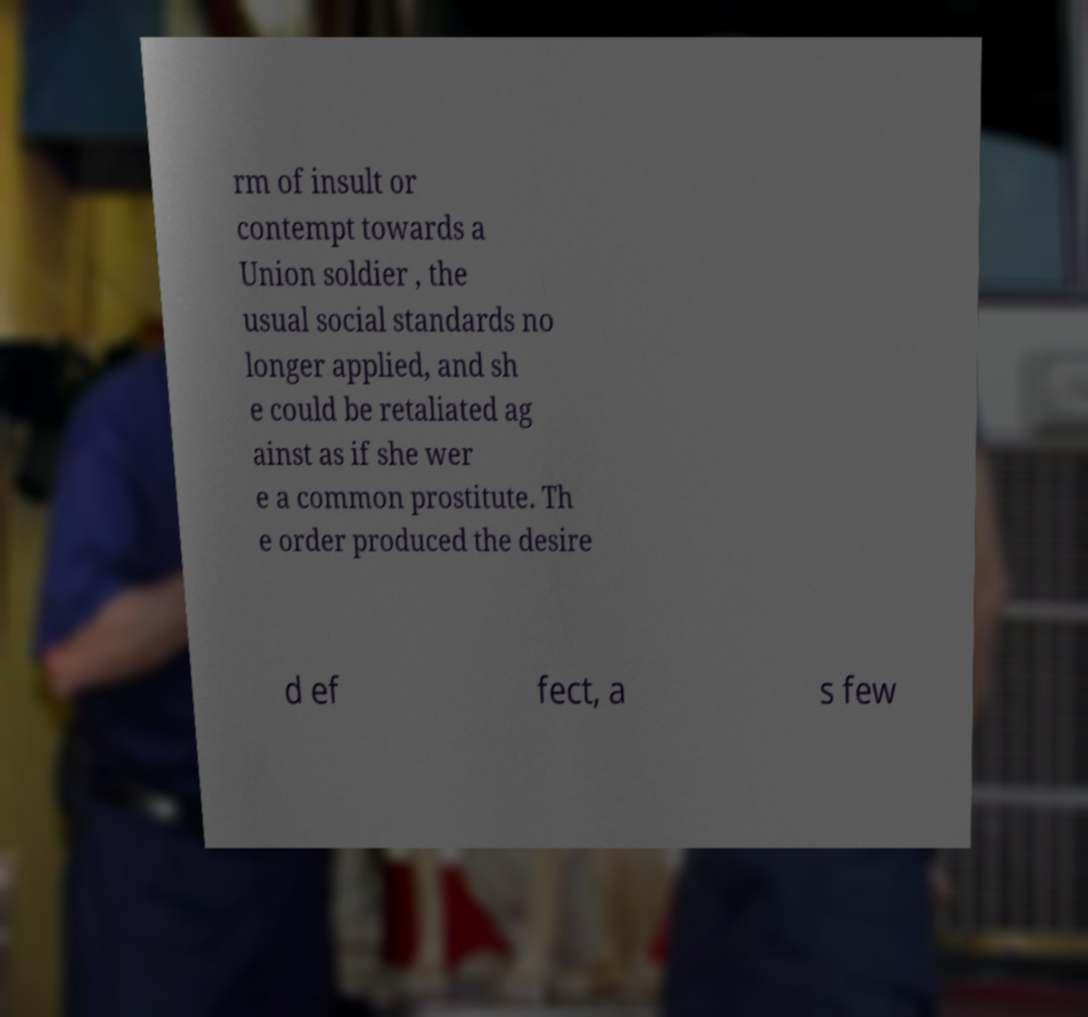Can you accurately transcribe the text from the provided image for me? rm of insult or contempt towards a Union soldier , the usual social standards no longer applied, and sh e could be retaliated ag ainst as if she wer e a common prostitute. Th e order produced the desire d ef fect, a s few 